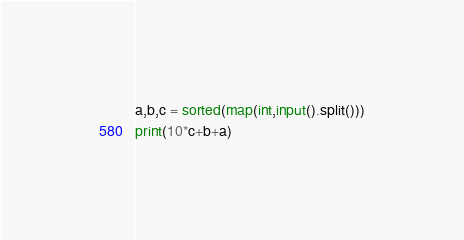Convert code to text. <code><loc_0><loc_0><loc_500><loc_500><_Python_>
a,b,c = sorted(map(int,input().split()))
print(10*c+b+a)</code> 